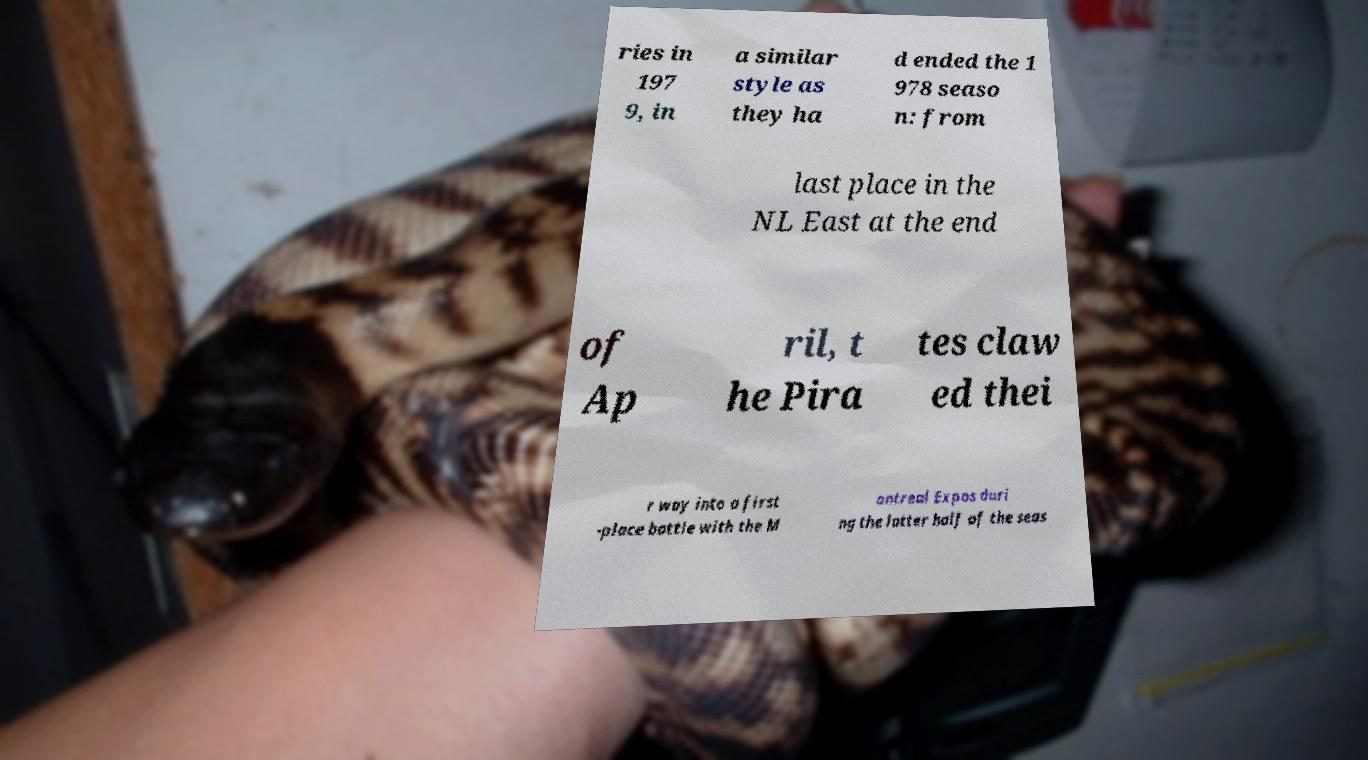Could you extract and type out the text from this image? ries in 197 9, in a similar style as they ha d ended the 1 978 seaso n: from last place in the NL East at the end of Ap ril, t he Pira tes claw ed thei r way into a first -place battle with the M ontreal Expos duri ng the latter half of the seas 